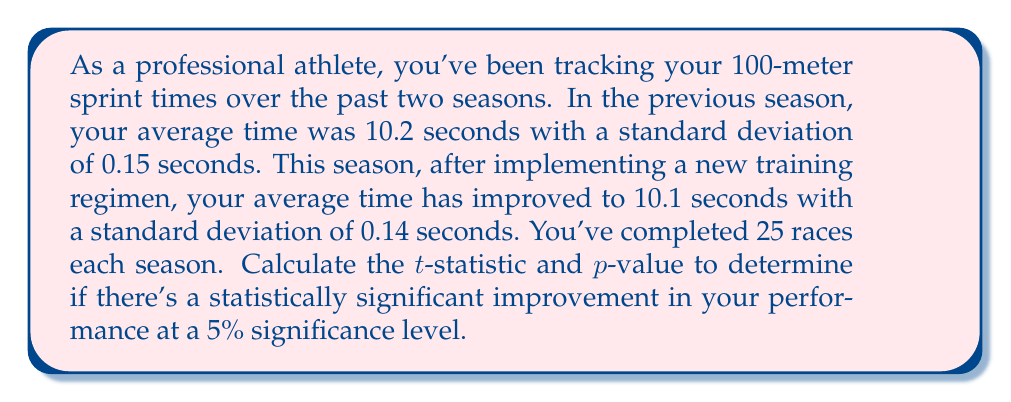Solve this math problem. To determine if there's a statistically significant improvement in performance, we'll use a two-sample t-test for independent samples. We'll follow these steps:

1. Calculate the pooled standard deviation:
   $$s_p = \sqrt{\frac{(n_1 - 1)s_1^2 + (n_2 - 1)s_2^2}{n_1 + n_2 - 2}}$$
   Where:
   $n_1 = n_2 = 25$ (sample size for each season)
   $s_1 = 0.15$ (standard deviation for previous season)
   $s_2 = 0.14$ (standard deviation for current season)

   $$s_p = \sqrt{\frac{(25 - 1)(0.15)^2 + (25 - 1)(0.14)^2}{25 + 25 - 2}} = 0.1452$$

2. Calculate the t-statistic:
   $$t = \frac{\bar{x}_1 - \bar{x}_2}{s_p\sqrt{\frac{2}{n}}}$$
   Where:
   $\bar{x}_1 = 10.2$ (mean for previous season)
   $\bar{x}_2 = 10.1$ (mean for current season)
   $n = 25$ (sample size for each season)

   $$t = \frac{10.2 - 10.1}{0.1452\sqrt{\frac{2}{25}}} = 2.4414$$

3. Calculate degrees of freedom:
   $df = n_1 + n_2 - 2 = 25 + 25 - 2 = 48$

4. Find the critical t-value for a two-tailed test at 5% significance level:
   $t_{crit} = 2.011$ (from t-distribution table)

5. Calculate the p-value:
   Using a t-distribution calculator or table, we find that the p-value for $t = 2.4414$ and $df = 48$ is approximately 0.0184.

6. Compare the t-statistic to the critical t-value and the p-value to the significance level:
   $|t| = 2.4414 > t_{crit} = 2.011$
   $p-value = 0.0184 < 0.05$ (significance level)

Since the absolute value of the t-statistic is greater than the critical t-value and the p-value is less than the significance level, we reject the null hypothesis.
Answer: The t-statistic is 2.4414 and the p-value is 0.0184. Since the p-value is less than the 5% significance level, there is statistically significant evidence of improvement in performance. 